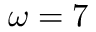Convert formula to latex. <formula><loc_0><loc_0><loc_500><loc_500>\omega = 7</formula> 